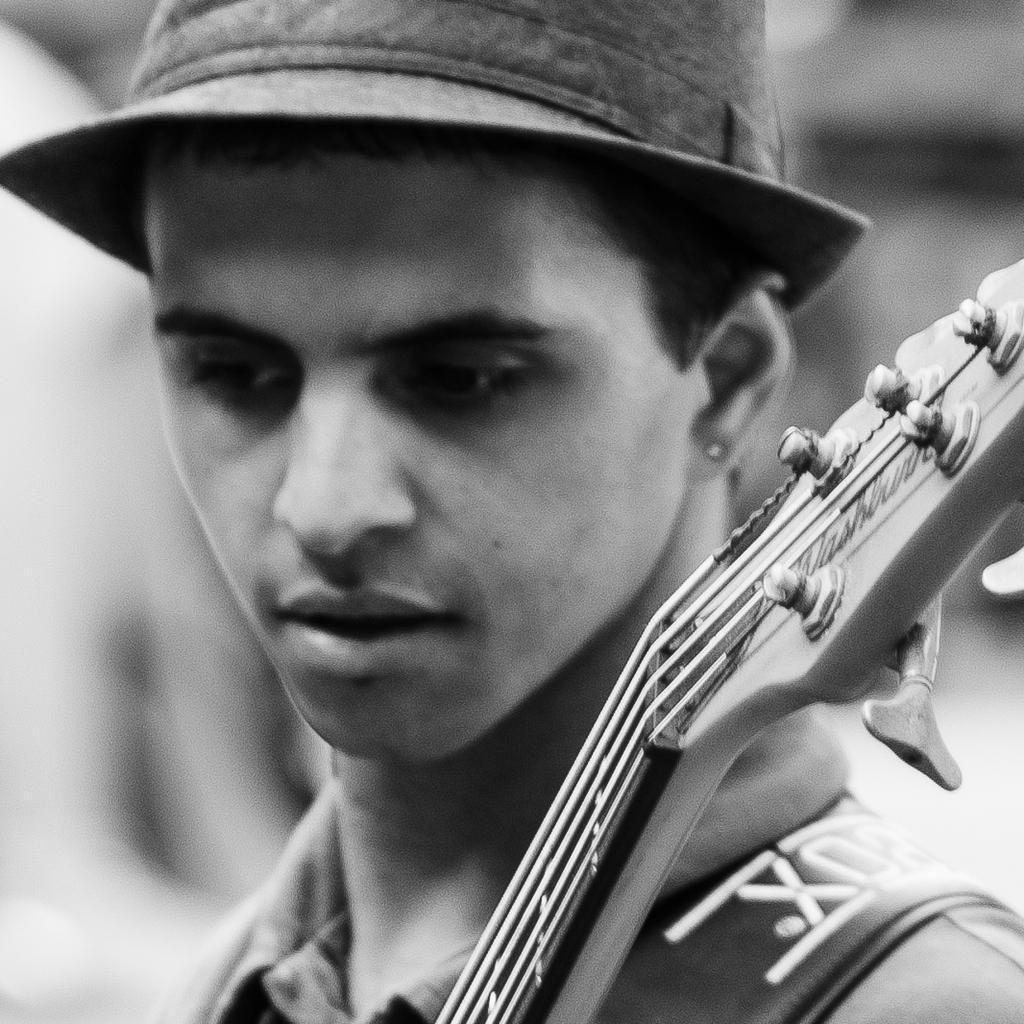Could you give a brief overview of what you see in this image? In this image in the front there is a person and there is a musical instrument and the background is blurry. 